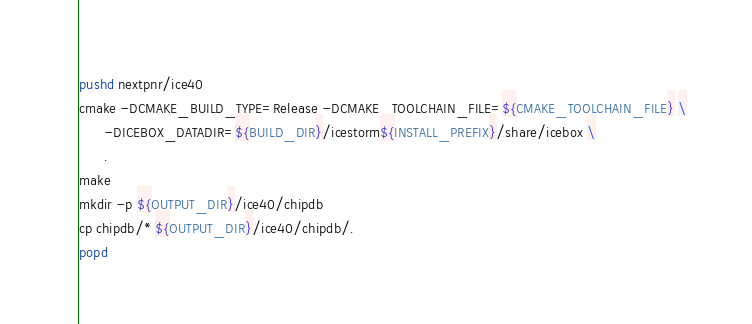<code> <loc_0><loc_0><loc_500><loc_500><_Bash_>pushd nextpnr/ice40
cmake -DCMAKE_BUILD_TYPE=Release -DCMAKE_TOOLCHAIN_FILE=${CMAKE_TOOLCHAIN_FILE} \
      -DICEBOX_DATADIR=${BUILD_DIR}/icestorm${INSTALL_PREFIX}/share/icebox \
      .
make
mkdir -p ${OUTPUT_DIR}/ice40/chipdb
cp chipdb/* ${OUTPUT_DIR}/ice40/chipdb/.
popd</code> 